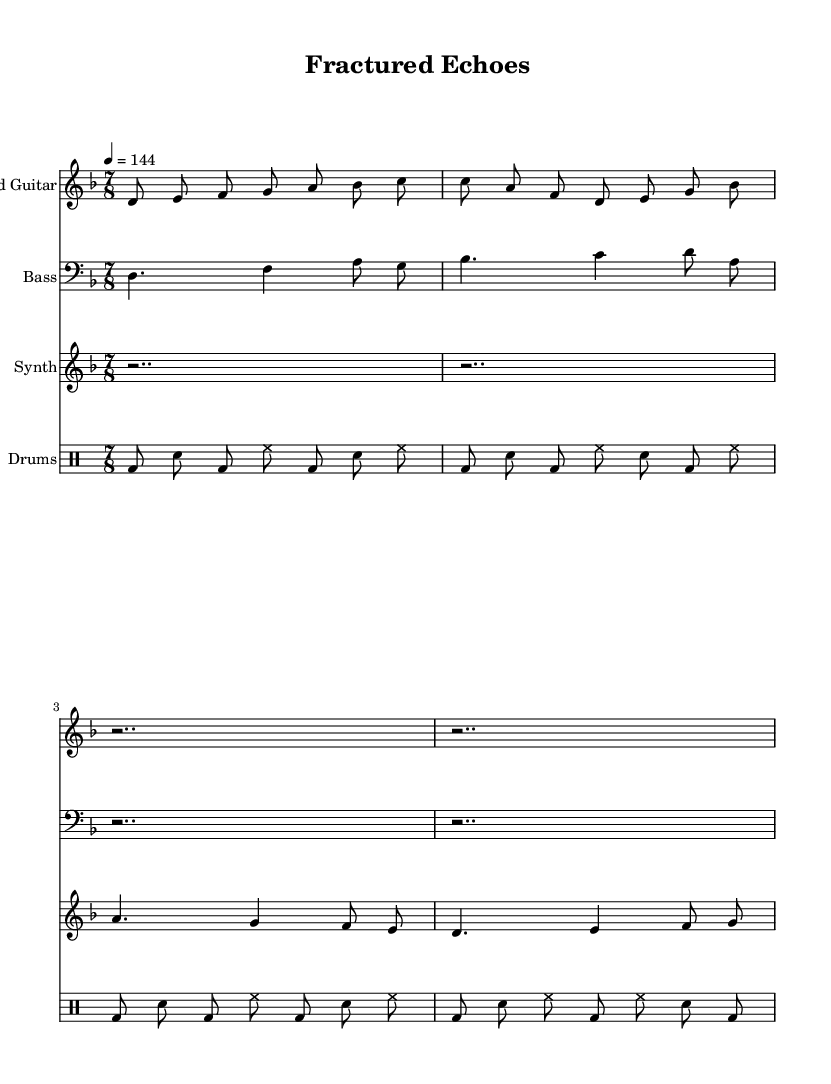What is the key signature of this music? The key signature is indicated at the beginning of the sheet music, where it shows a flat symbol next to the letter "D", meaning it is in D minor.
Answer: D minor What is the time signature of this music? The time signature, located right after the key signature, shows 7/8, which indicates there are seven beats in a measure and the eighth note gets one beat.
Answer: 7/8 What is the tempo marking of this music? The tempo marking is found above the staff, indicating "4 = 144". This means that there are 144 beats per minute, where a quarter note equals one beat.
Answer: 144 How many measures are there in the guitar part? By counting the music segments in the guitar part, there are a total of four measures visible. Each segment is separated by a vertical line.
Answer: 4 What is the dynamic marking in the synth part? There are no dynamic markings provided in the synth part at the indicated measure, indicating it may be played at a medium volume by default.
Answer: None Which instrument has the note A being played in the bass part? The bass part shows that the note A is played as the second note in measure 1 and the last note in measure 2, according to the notation.
Answer: Bass What style does this music relate to? The components, such as distorted guitar and found sounds, indicate a fusion style that blends industrial metal with elements of experimental music, expressing inner turmoil.
Answer: Fusion 